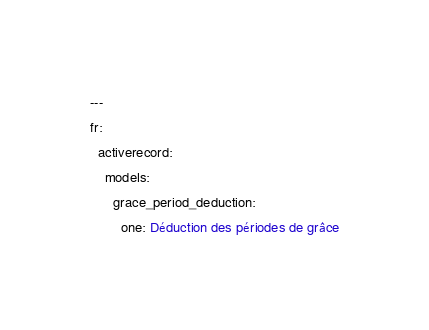Convert code to text. <code><loc_0><loc_0><loc_500><loc_500><_YAML_>---
fr:
  activerecord:
    models:
      grace_period_deduction:
        one: Déduction des périodes de grâce
</code> 